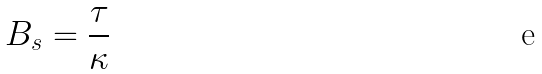<formula> <loc_0><loc_0><loc_500><loc_500>B _ { s } = \frac { \tau } { \kappa }</formula> 